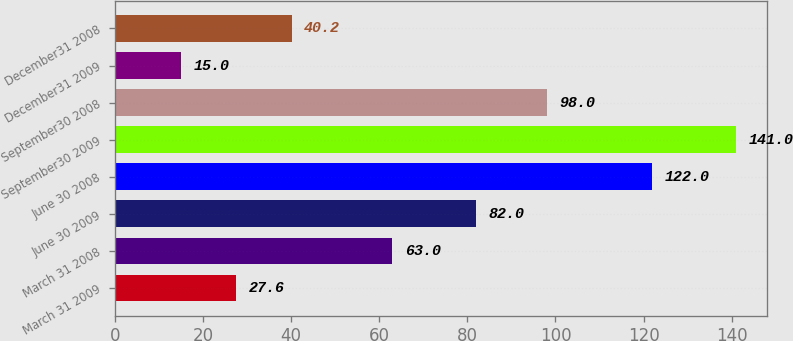Convert chart. <chart><loc_0><loc_0><loc_500><loc_500><bar_chart><fcel>March 31 2009<fcel>March 31 2008<fcel>June 30 2009<fcel>June 30 2008<fcel>September30 2009<fcel>September30 2008<fcel>December31 2009<fcel>December31 2008<nl><fcel>27.6<fcel>63<fcel>82<fcel>122<fcel>141<fcel>98<fcel>15<fcel>40.2<nl></chart> 